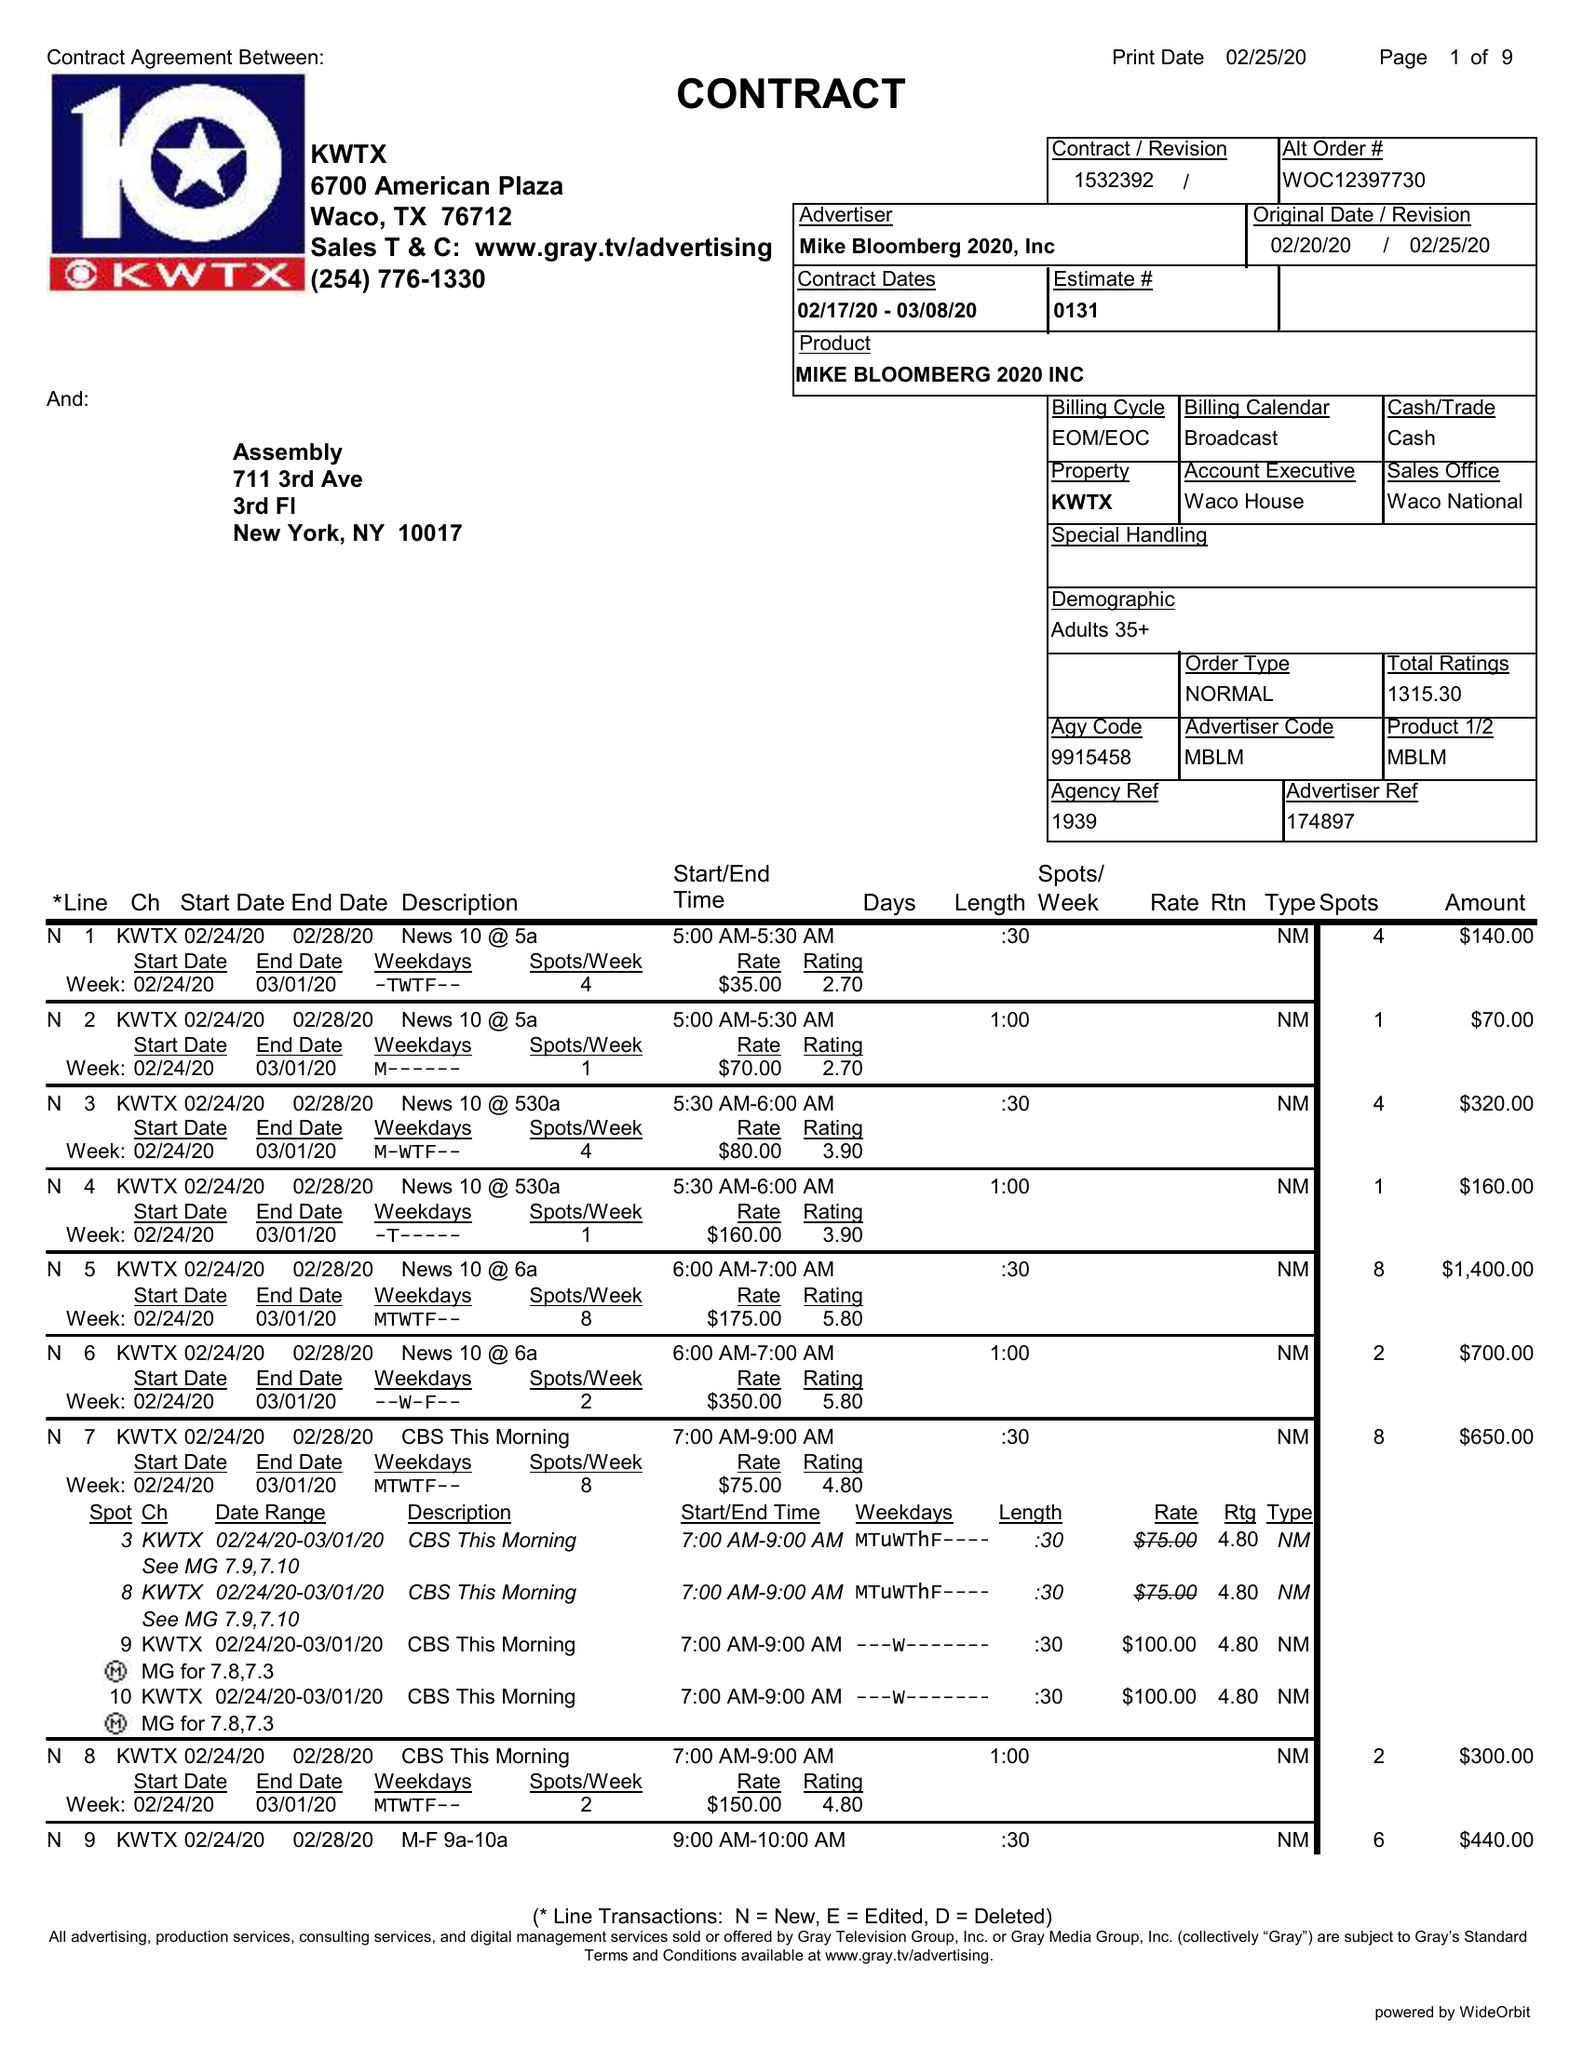What is the value for the gross_amount?
Answer the question using a single word or phrase. 54590.00 